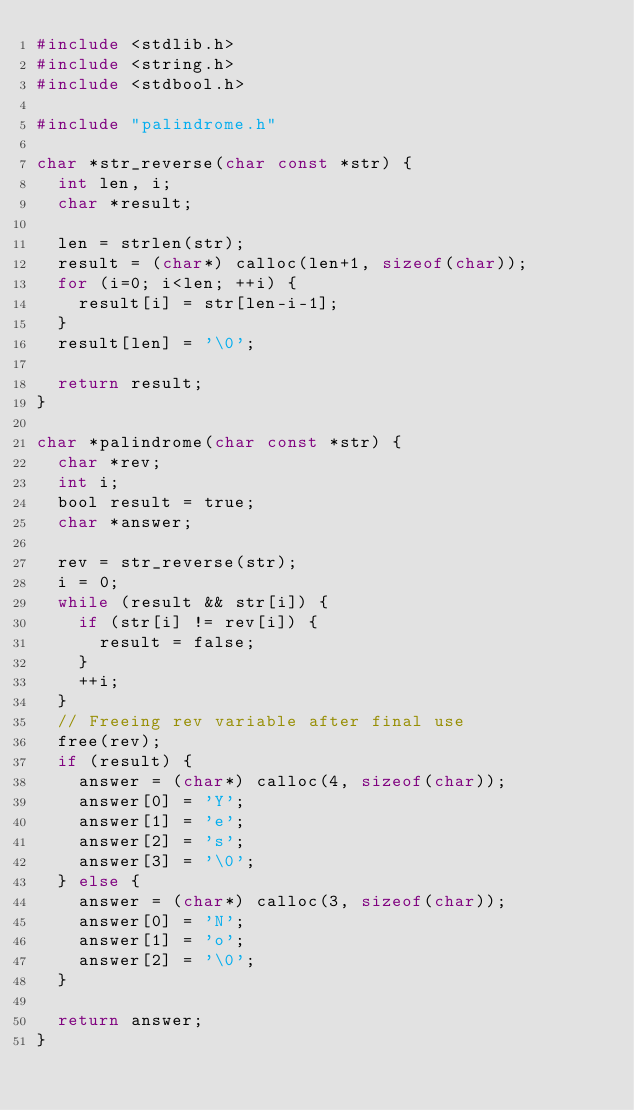Convert code to text. <code><loc_0><loc_0><loc_500><loc_500><_C_>#include <stdlib.h>
#include <string.h>
#include <stdbool.h>

#include "palindrome.h"

char *str_reverse(char const *str) {
  int len, i;
  char *result;

  len = strlen(str);
  result = (char*) calloc(len+1, sizeof(char));
  for (i=0; i<len; ++i) {
    result[i] = str[len-i-1];
  }
  result[len] = '\0';
  
  return result;
}

char *palindrome(char const *str) {
  char *rev;
  int i;
  bool result = true;
  char *answer;

  rev = str_reverse(str);
  i = 0;
  while (result && str[i]) {
    if (str[i] != rev[i]) {
      result = false;
    }
    ++i;
  }
  // Freeing rev variable after final use
  free(rev);
  if (result) {
    answer = (char*) calloc(4, sizeof(char));
    answer[0] = 'Y';
    answer[1] = 'e';
    answer[2] = 's';
    answer[3] = '\0';
  } else {
    answer = (char*) calloc(3, sizeof(char));
    answer[0] = 'N';
    answer[1] = 'o';
    answer[2] = '\0';
  }

  return answer;
}
</code> 